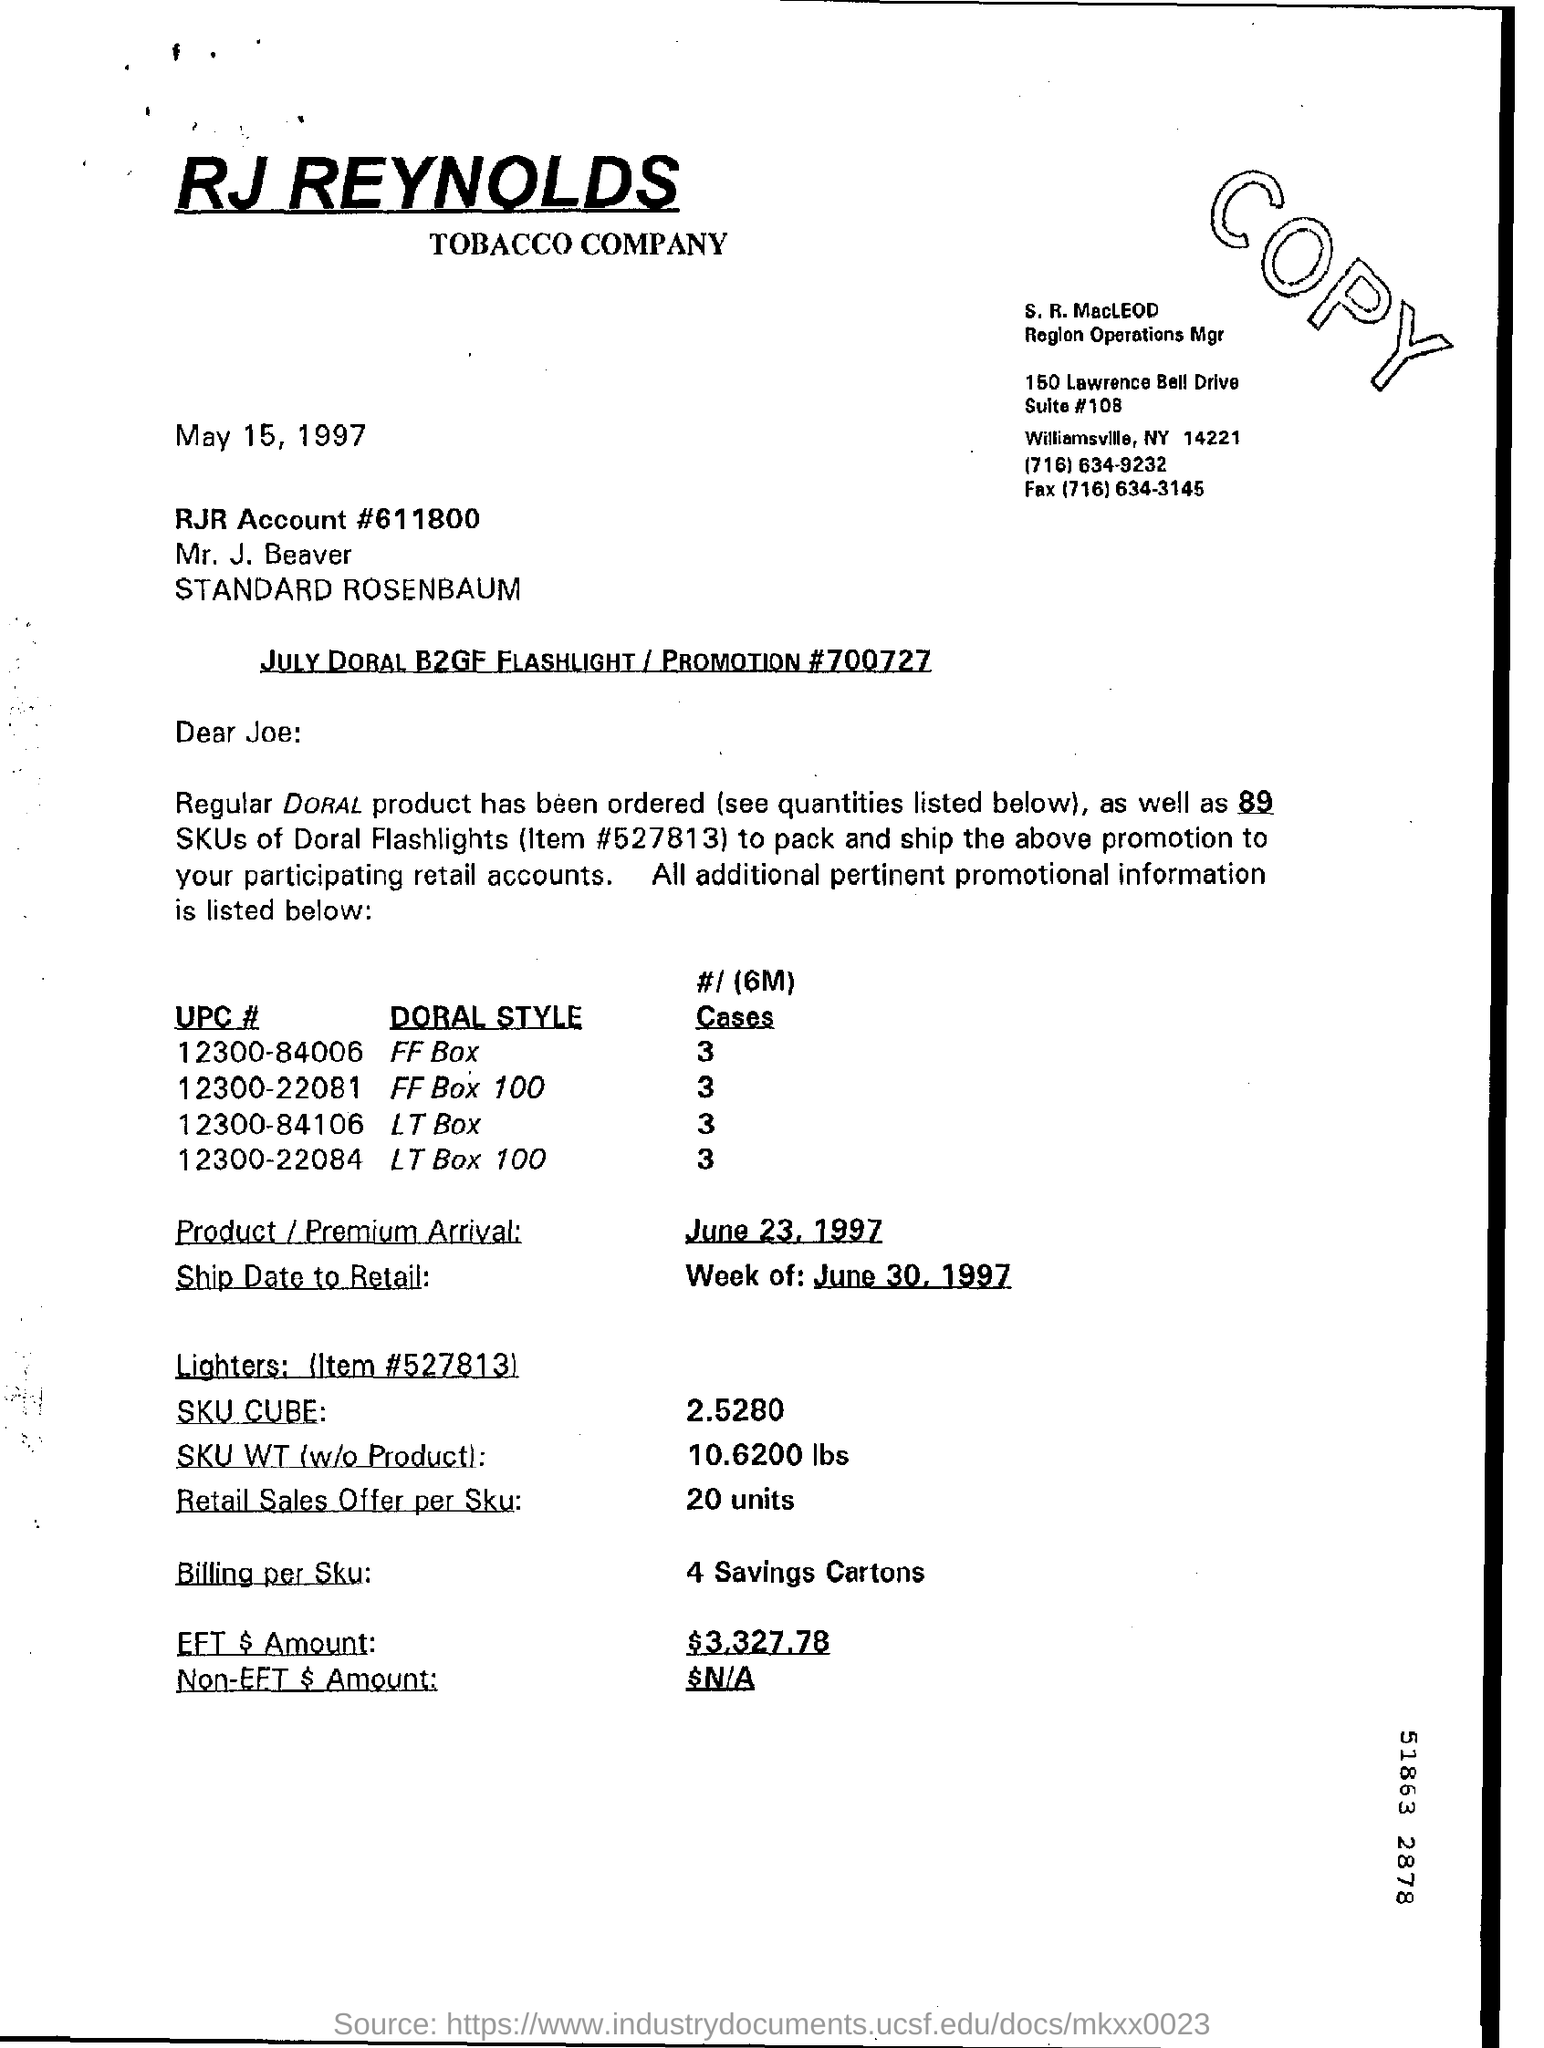List a handful of essential elements in this visual. The arrival date for the Product/Premium is June 23, 1997. The Retail Sales Offer per SKU is 20.. The company that is mentioned in the letterhead is RJ Reynolds. The EFT amount is $3,327.78. The weight of a SKU (without the product) is 10.6200 lbs. 